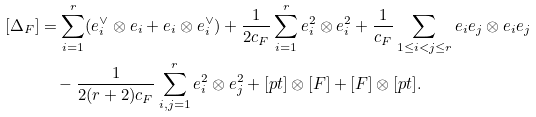<formula> <loc_0><loc_0><loc_500><loc_500>[ \Delta _ { F } ] & = \sum _ { i = 1 } ^ { r } ( e _ { i } ^ { \vee } \otimes e _ { i } + e _ { i } \otimes e _ { i } ^ { \vee } ) + \frac { 1 } { 2 c _ { F } } \sum _ { i = 1 } ^ { r } e _ { i } ^ { 2 } \otimes e _ { i } ^ { 2 } + \frac { 1 } { c _ { F } } \sum _ { 1 \leq i < j \leq r } e _ { i } e _ { j } \otimes e _ { i } e _ { j } \\ & \quad - \frac { 1 } { 2 ( r + 2 ) c _ { F } } \sum _ { i , j = 1 } ^ { r } e _ { i } ^ { 2 } \otimes e _ { j } ^ { 2 } + [ p t ] \otimes [ F ] + [ F ] \otimes [ p t ] .</formula> 